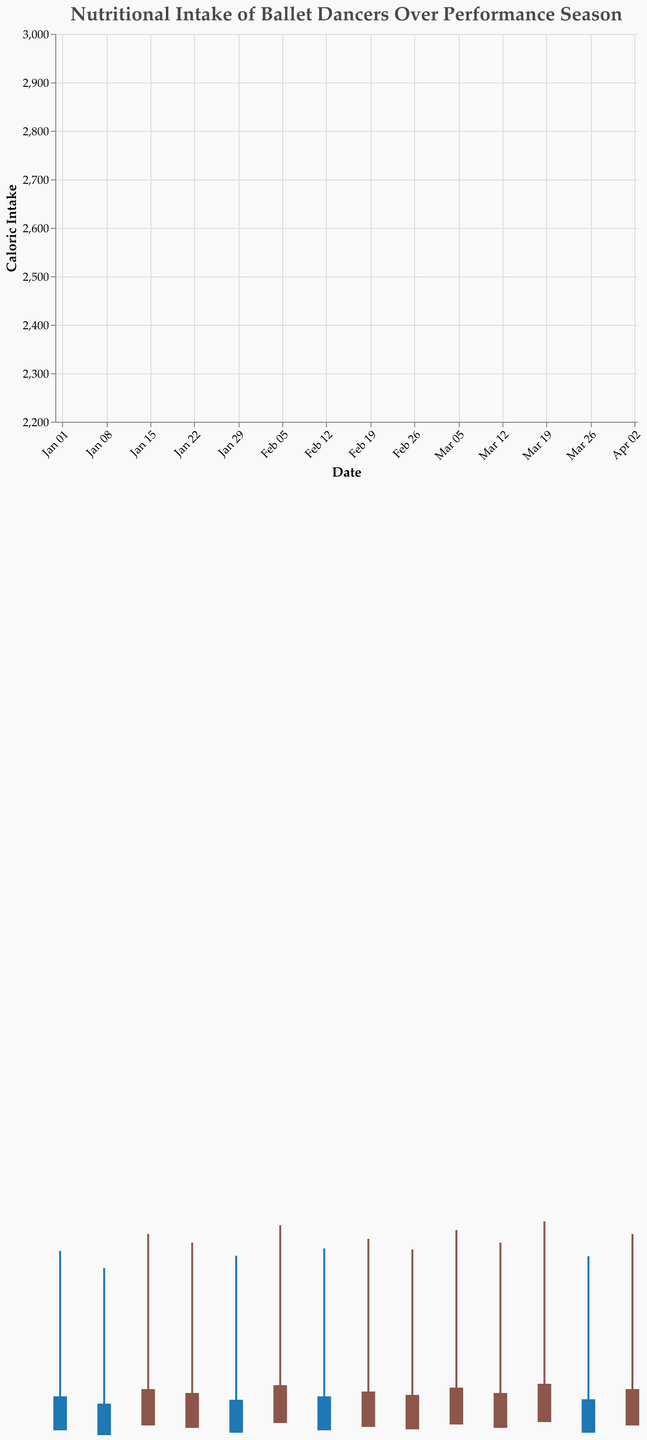What is the range of caloric intake for the dates shown in the chart? The caloric intake ranges from the minimum value to the maximum value observed in the data points. By visually scanning, the lowest caloric intake is 2300 on January 8, and the highest is 2950 on March 19.
Answer: 2300 to 2950 On which date was the highest caloric intake observed? To find the highest caloric intake, look for the tallest candlestick bar. The maximum caloric intake is 2950, which occurs on March 19.
Answer: March 19 How does the caloric intake on Jan 22 compare to that on Jan 29? Compare the heights of the candlestick bars for Jan 22 (2700) and Jan 29 (2500). Calculate the difference: 2700 - 2500 = 200.
Answer: 200 higher on Jan 22 What is the average protein intake for the dates listed? Sum the protein intakes and divide by the number of dates. Total protein intake is (120 + 110 + 130 + 125 + 115 + 135 + 120 + 127 + 122 + 132 + 125 + 137 + 115 + 130) = 1763. The number of dates is 14. Average: 1763 / 14 = 126.64
Answer: 126.64 g Which date has the lowest combined intake of protein and fat? The combined intake of protein and fat is represented by the "close" value in the candlestick. The lowest "close" value is 185 on Jan 8.
Answer: January 8 Compare the protein and carb intake on Feb 5. The candlestick shows "open" (protein) and "high" (protein + fat + carb). Protein: 135; Carbs: Subtract (protein + fat) from (protein + fat + carb) = 135 + 78 + 330 - (135 + 78) = 330.
Answer: Protein: 135 g, Carbs: 330 g What are the minimum and maximum values for carbohydrate intake? From the data, the lowest carbohydrate intake is 280 g on Jan 8, and the highest is 335 g on Mar 19.
Answer: 280 to 335 g Is there a date where the caloric intake is exactly 2500? Check the data or candlestick heights for an exact caloric intake of 2500. It occurs on Jan 29 and Mar 26.
Answer: Yes, Jan 29 and Mar 26 